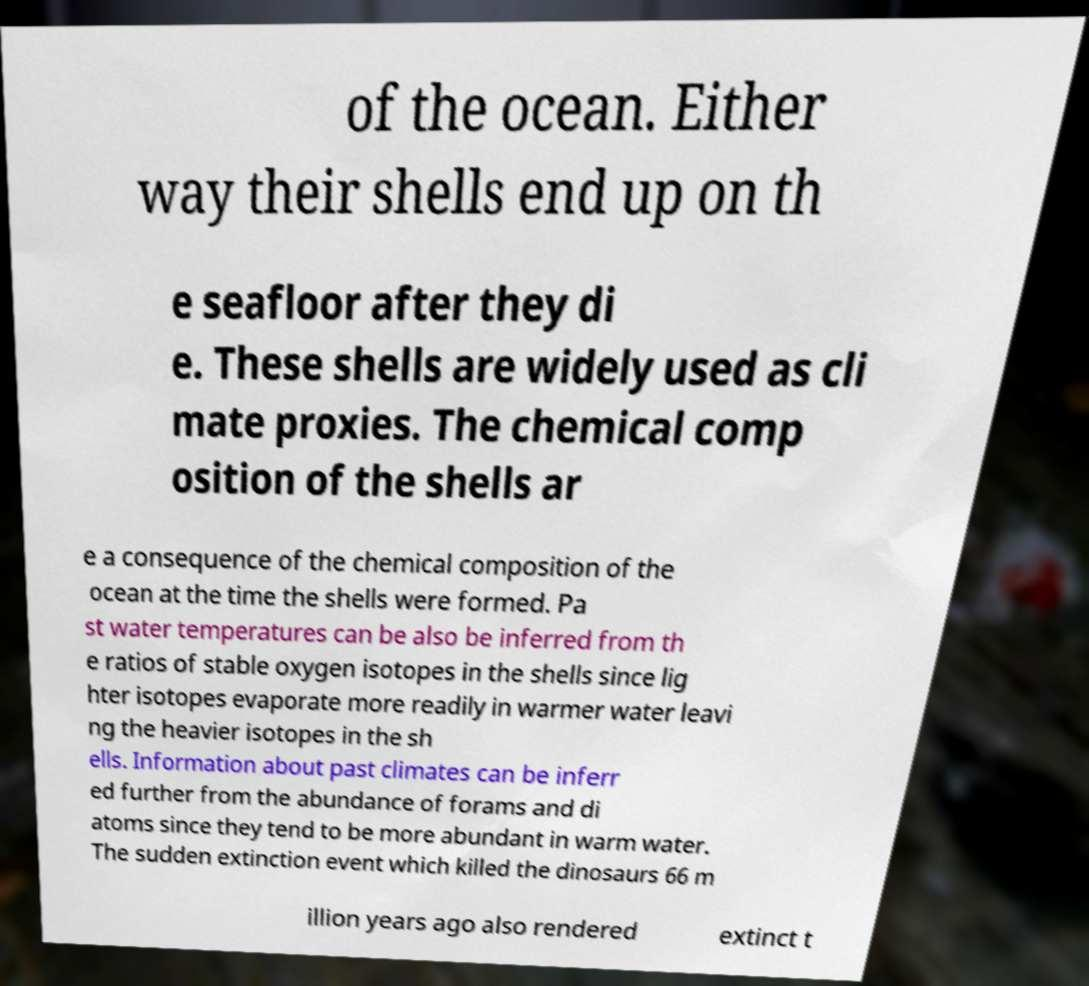What messages or text are displayed in this image? I need them in a readable, typed format. of the ocean. Either way their shells end up on th e seafloor after they di e. These shells are widely used as cli mate proxies. The chemical comp osition of the shells ar e a consequence of the chemical composition of the ocean at the time the shells were formed. Pa st water temperatures can be also be inferred from th e ratios of stable oxygen isotopes in the shells since lig hter isotopes evaporate more readily in warmer water leavi ng the heavier isotopes in the sh ells. Information about past climates can be inferr ed further from the abundance of forams and di atoms since they tend to be more abundant in warm water. The sudden extinction event which killed the dinosaurs 66 m illion years ago also rendered extinct t 